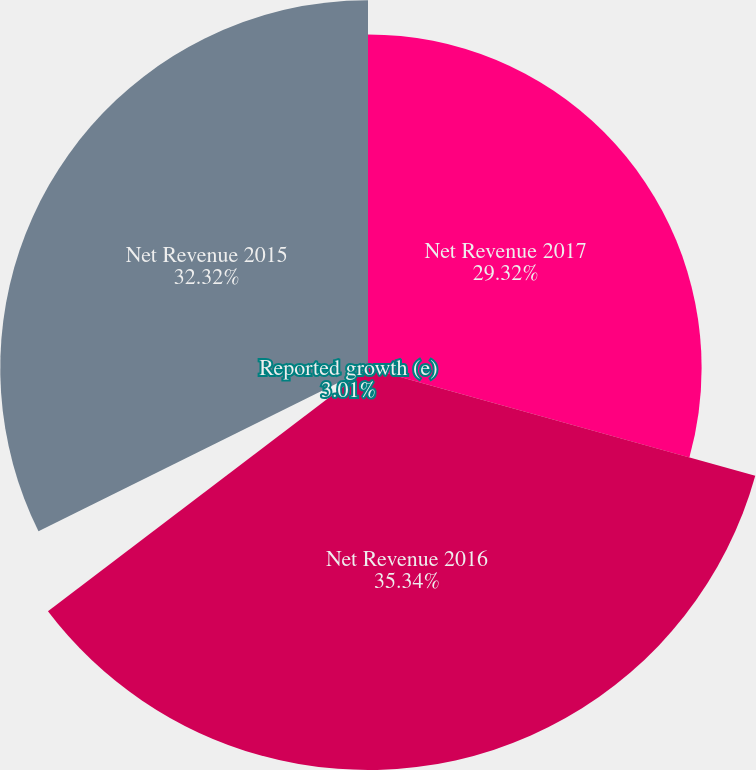Convert chart. <chart><loc_0><loc_0><loc_500><loc_500><pie_chart><fcel>Net Revenue 2017<fcel>Net Revenue 2016<fcel>Effective net pricing (b)<fcel>Reported growth (e)<fcel>Net Revenue 2015<nl><fcel>29.32%<fcel>35.33%<fcel>0.01%<fcel>3.01%<fcel>32.32%<nl></chart> 